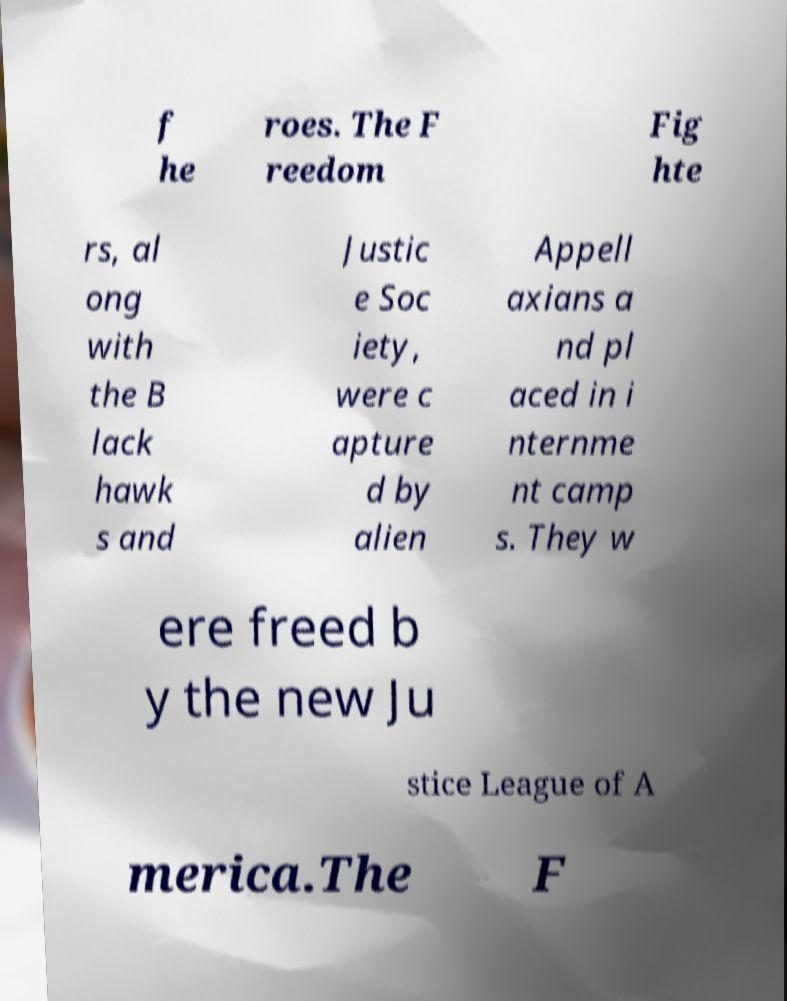There's text embedded in this image that I need extracted. Can you transcribe it verbatim? f he roes. The F reedom Fig hte rs, al ong with the B lack hawk s and Justic e Soc iety, were c apture d by alien Appell axians a nd pl aced in i nternme nt camp s. They w ere freed b y the new Ju stice League of A merica.The F 